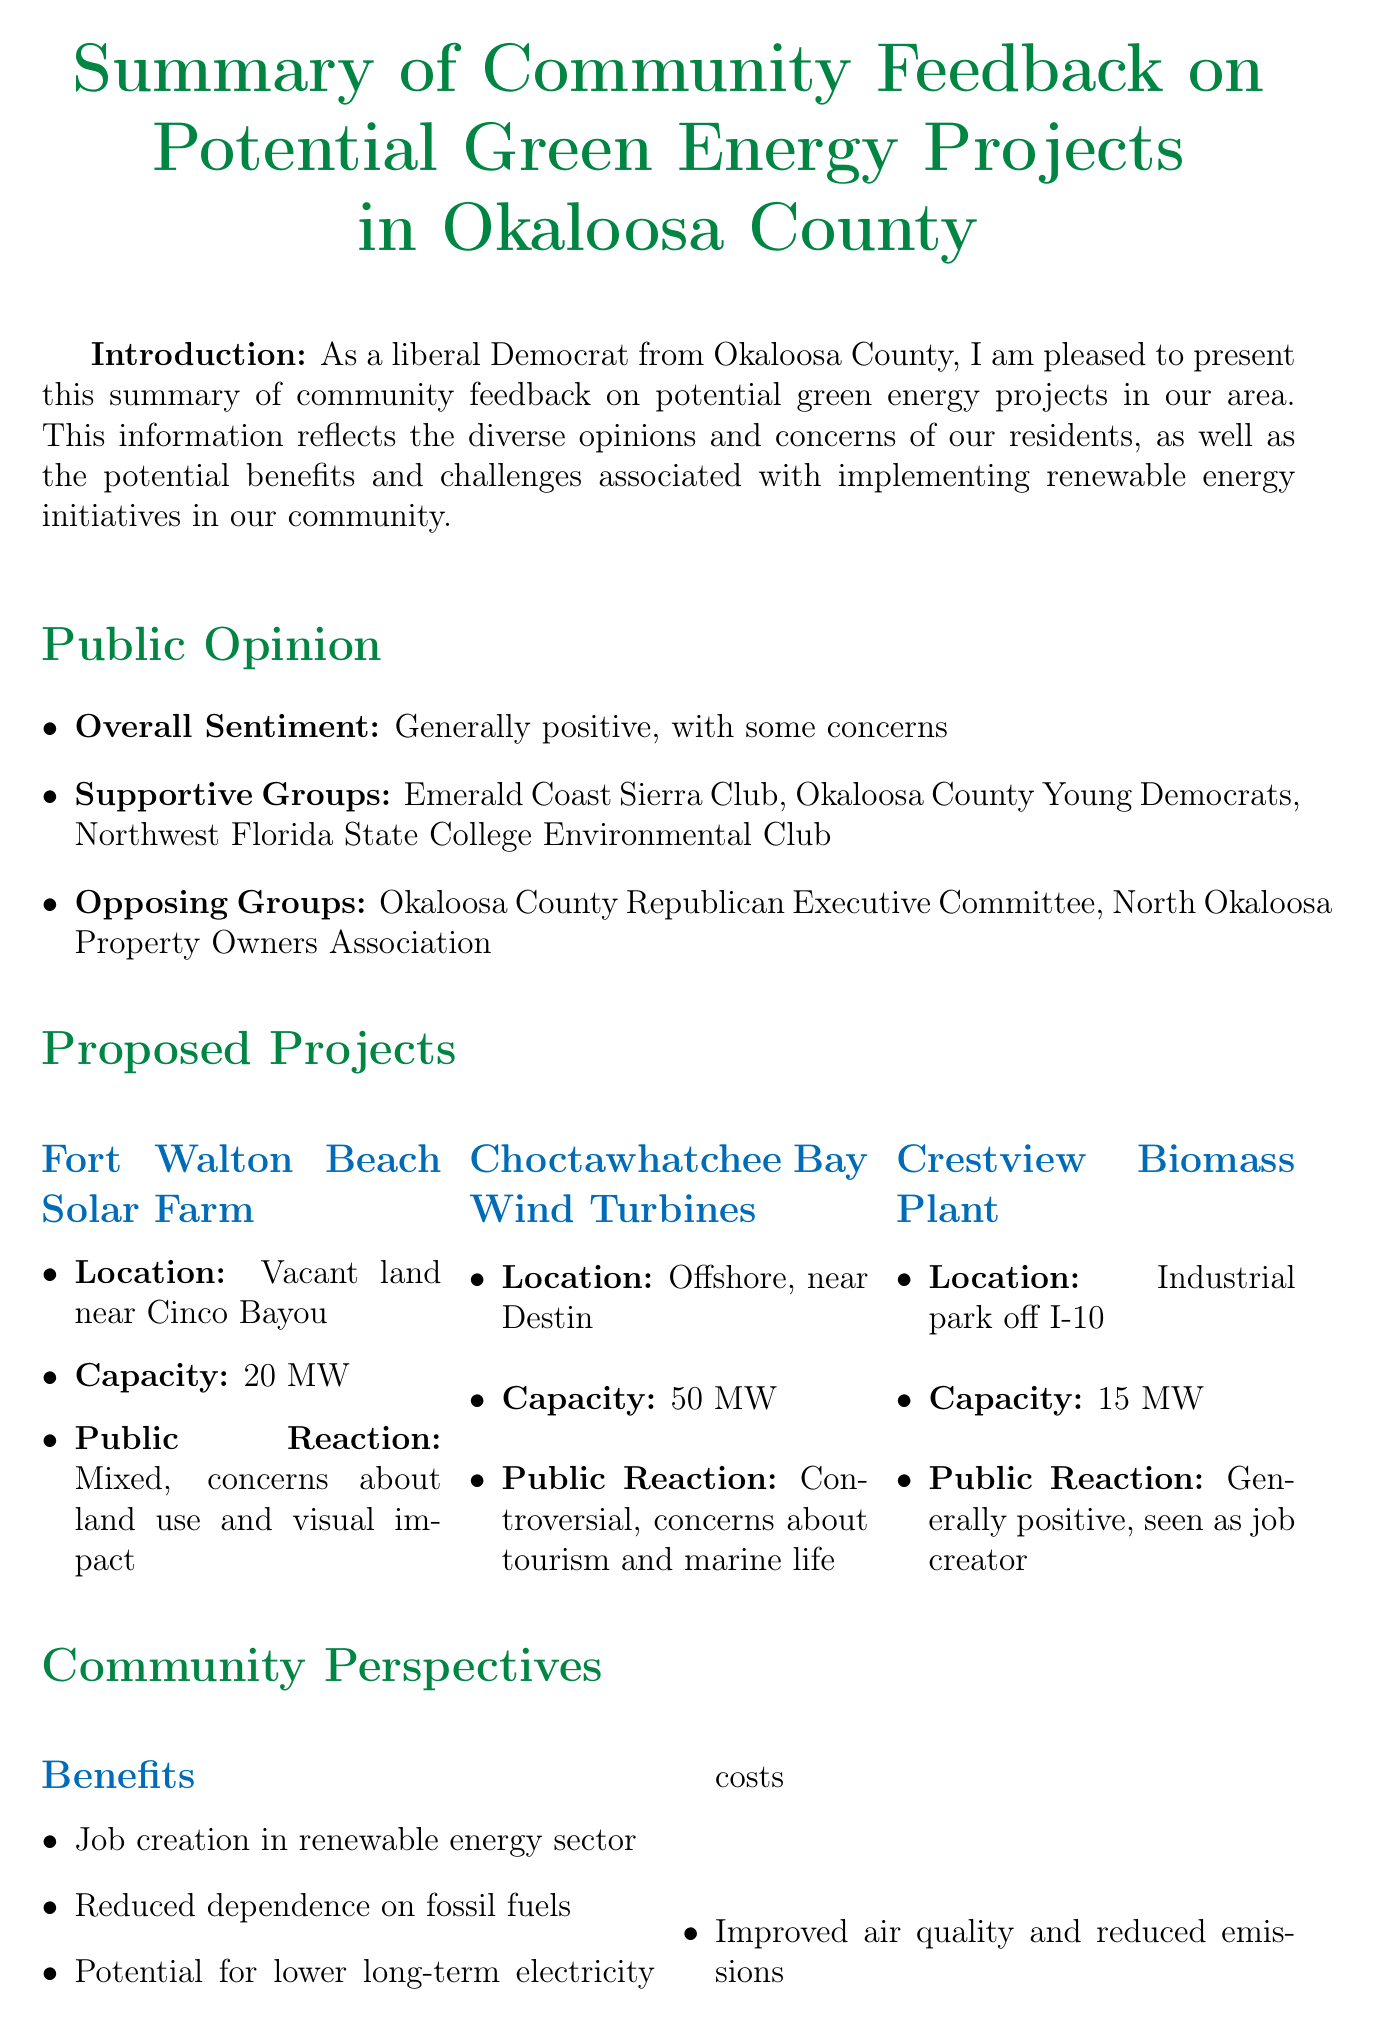what is the overall sentiment of community feedback? The overall sentiment reflects the general opinions of residents regarding green energy projects, which is stated in the document.
Answer: Generally positive, with some concerns who is the mayor of Fort Walton Beach? The name of the mayor is mentioned in the section regarding local government stance.
Answer: Enthusiastic about solar project how many megawatts is the capacity of the Choctawhatchee Bay Wind Turbines? This information can be found in the description of the proposed wind turbine project.
Answer: 50 MW what is one of the community benefits listed? The document outlines various community benefits of potential green energy projects.
Answer: Job creation in the renewable energy sector what is the estimated job creation over five years? The estimated job creation is provided in the economic impact section of the memo.
Answer: 200-300 new jobs over 5 years which group opposes the renewable energy projects? This question pertains to the list of opposing groups mentioned in the public opinion section.
Answer: Okaloosa County Republican Executive Committee what type of facility is the Crestview Biomass Plant? The document describes the type of proposed project and its location.
Answer: Biomass Plant what step involves exploring funding opportunities? The next steps section outlines actions to be taken for green energy projects.
Answer: Explore federal and state funding opportunities for green energy initiatives 